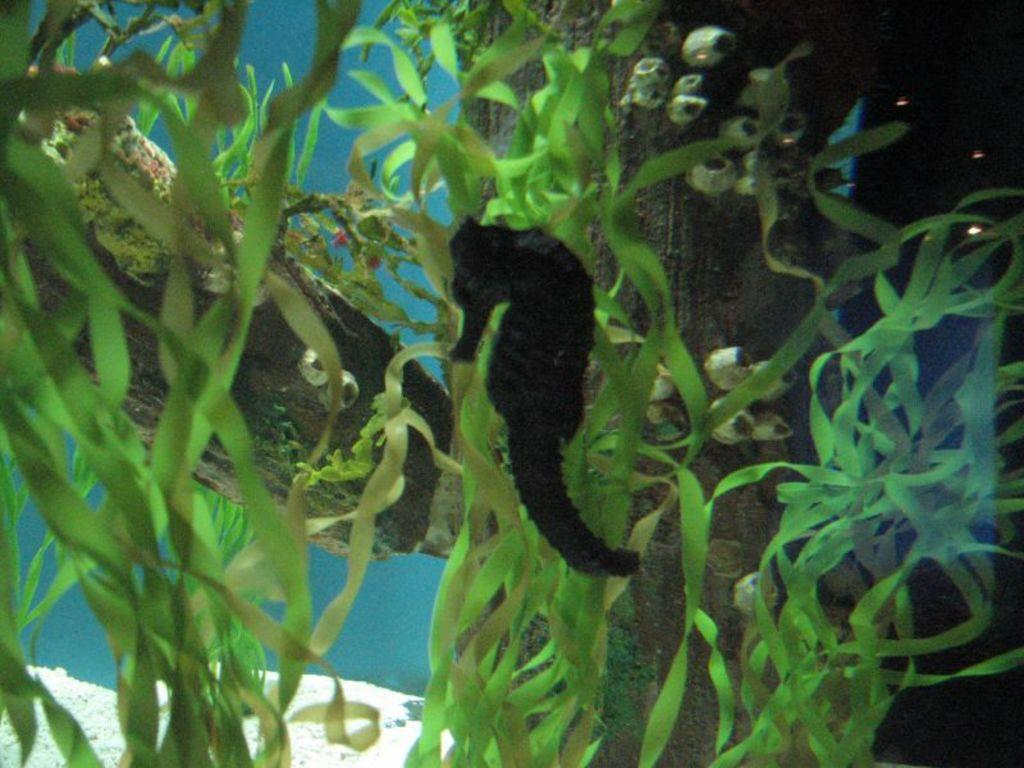What is the primary subject of the image? The image depicts water. What type of animal can be seen in the water? There is a seahorse in the water. What else can be found in the water besides the seahorse? There are marine plants in the water. What type of meat can be seen hanging from the marine plants in the image? There is no meat present in the image; it features water, a seahorse, and marine plants. 